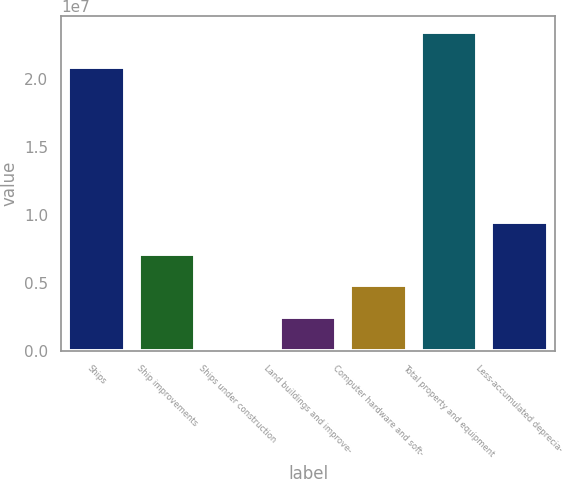Convert chart. <chart><loc_0><loc_0><loc_500><loc_500><bar_chart><fcel>Ships<fcel>Ship improvements<fcel>Ships under construction<fcel>Land buildings and improve-<fcel>Computer hardware and soft-<fcel>Total property and equipment<fcel>Less-accumulated deprecia-<nl><fcel>2.08556e+07<fcel>7.1513e+06<fcel>169274<fcel>2.49662e+06<fcel>4.82396e+06<fcel>2.34427e+07<fcel>9.47865e+06<nl></chart> 